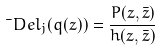Convert formula to latex. <formula><loc_0><loc_0><loc_500><loc_500>\bar { \ } D e l _ { j } ( q ( z ) ) = \frac { P ( z , \bar { z } ) } { h ( z , \bar { z } ) }</formula> 